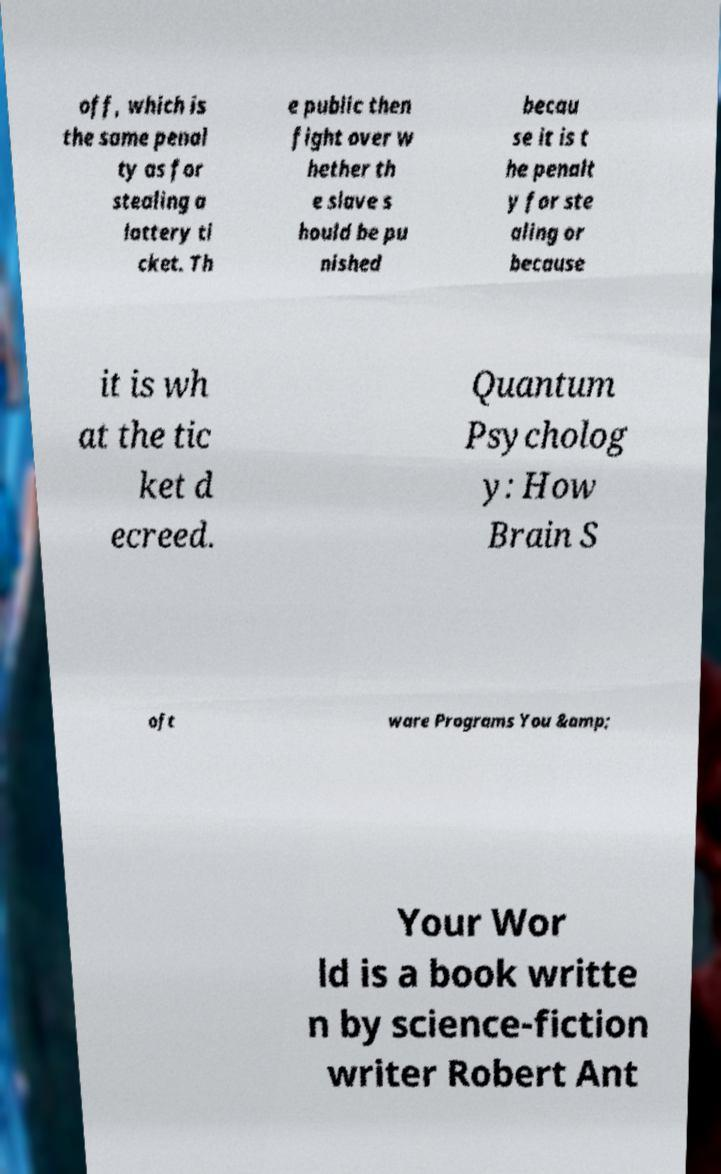There's text embedded in this image that I need extracted. Can you transcribe it verbatim? off, which is the same penal ty as for stealing a lottery ti cket. Th e public then fight over w hether th e slave s hould be pu nished becau se it is t he penalt y for ste aling or because it is wh at the tic ket d ecreed. Quantum Psycholog y: How Brain S oft ware Programs You &amp; Your Wor ld is a book writte n by science-fiction writer Robert Ant 